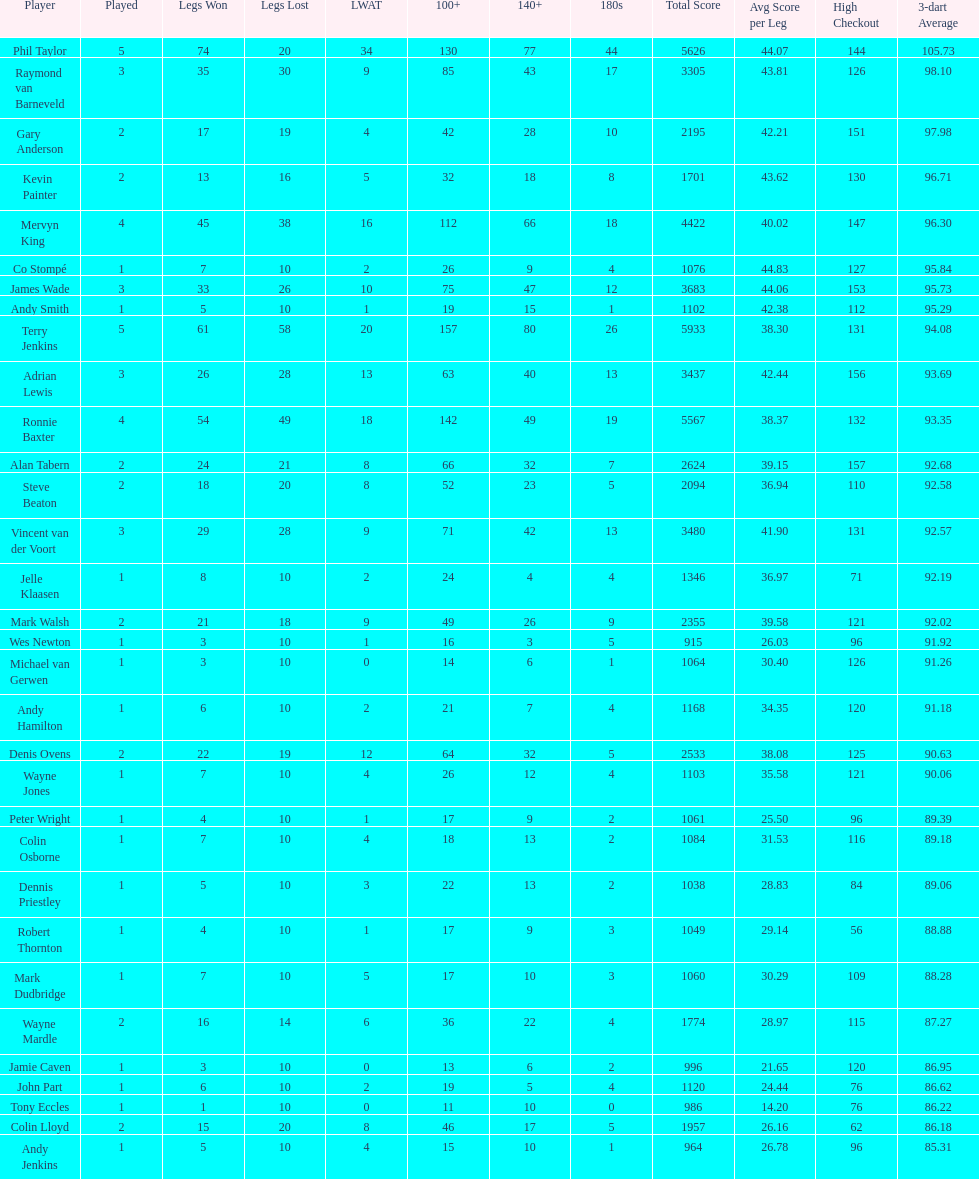Mark walsh's average is above/below 93? Below. 